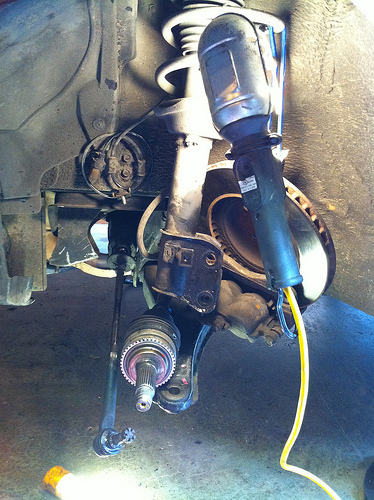<image>
Can you confirm if the machine is in front of the light? No. The machine is not in front of the light. The spatial positioning shows a different relationship between these objects. 